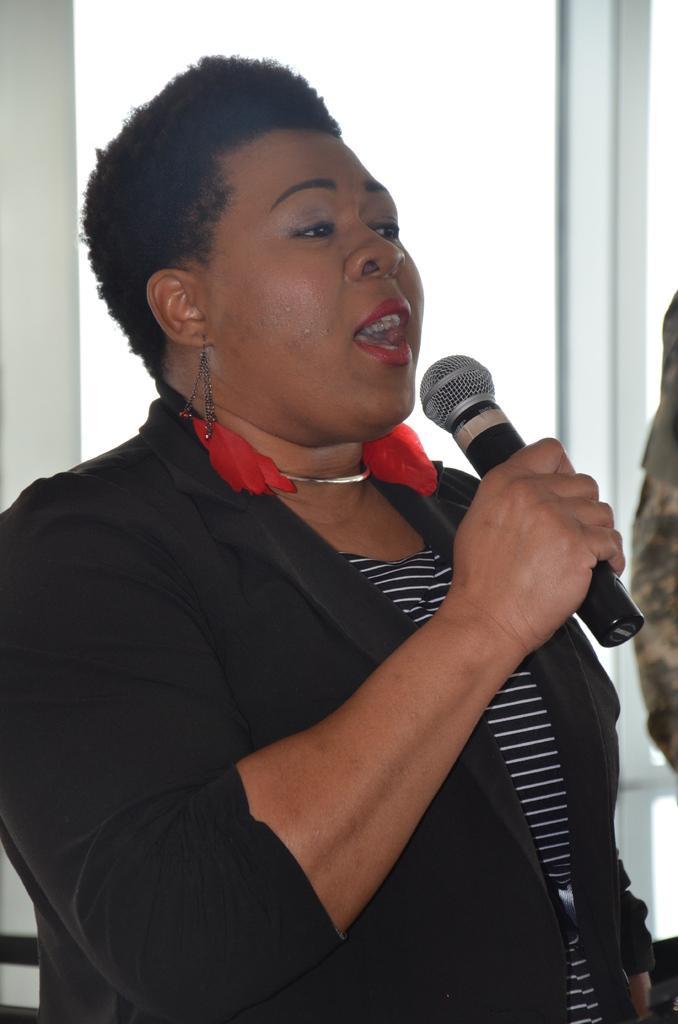Please provide a concise description of this image. In this picture we can see a woman holding a microphone and speaking something as we can see her mouth, in the background we can see one glass. 